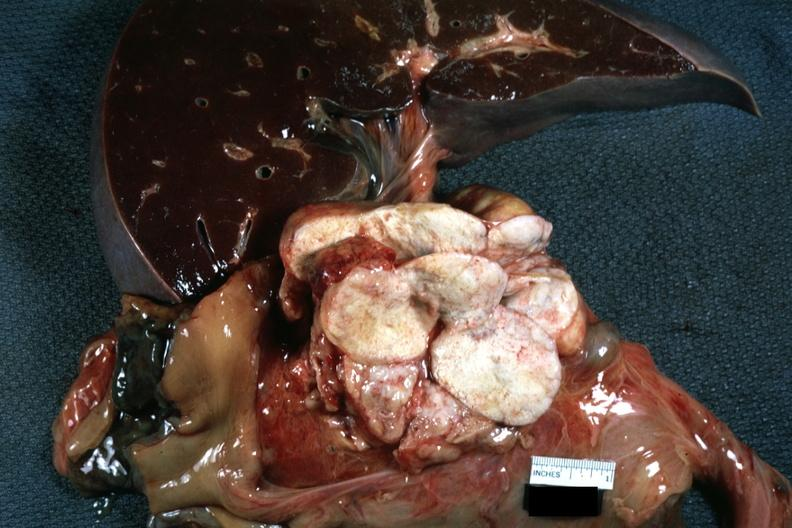what does this image show?
Answer the question using a single word or phrase. Nodes at tail of pancreas massively replaced by metastatic lung carcinoma 